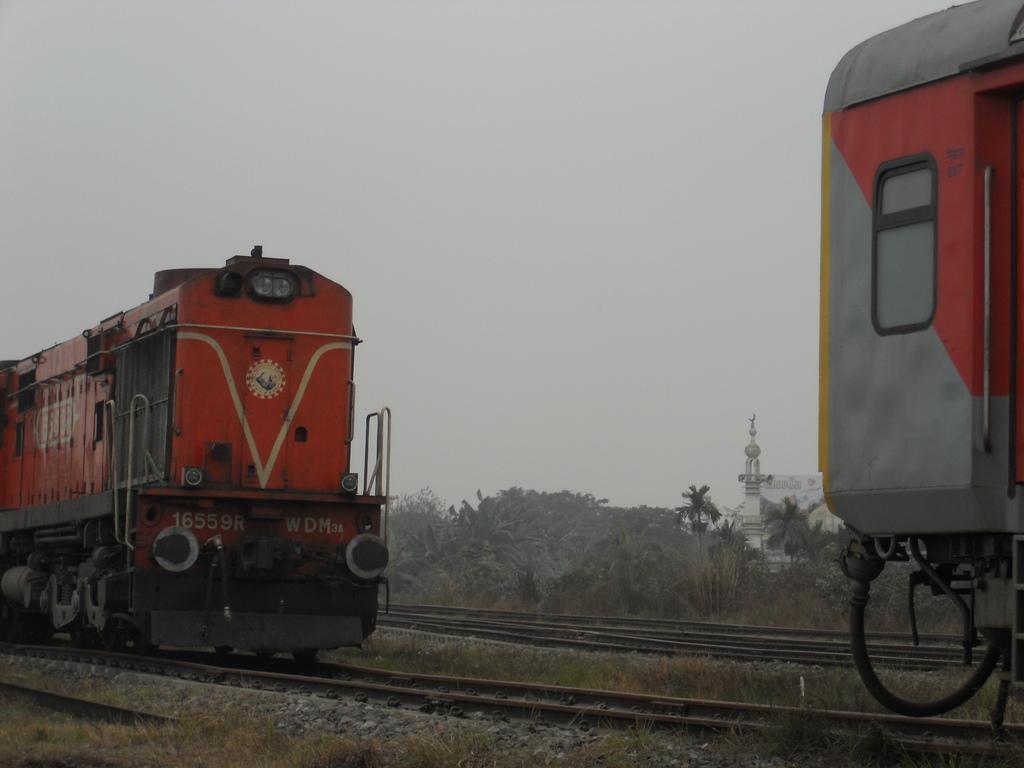Please provide a concise description of this image. In this image we can see the trains on the track. We can also see some stones, grass, a group of trees, a tower and the sky which looks cloudy. 